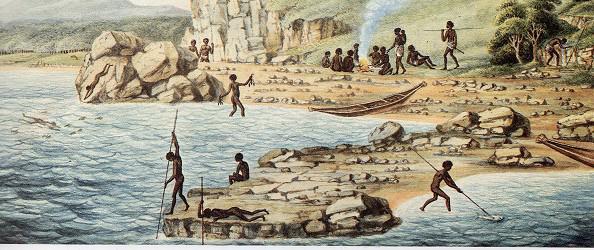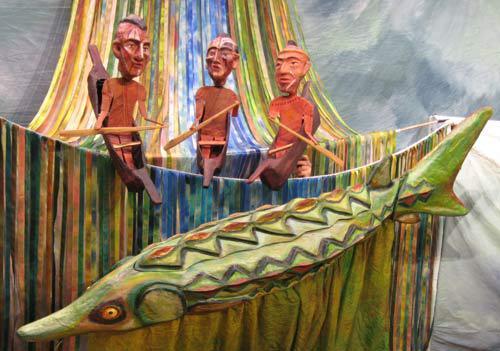The first image is the image on the left, the second image is the image on the right. Analyze the images presented: Is the assertion "In one image there are six or more men in a boat being paddled through water." valid? Answer yes or no. No. 